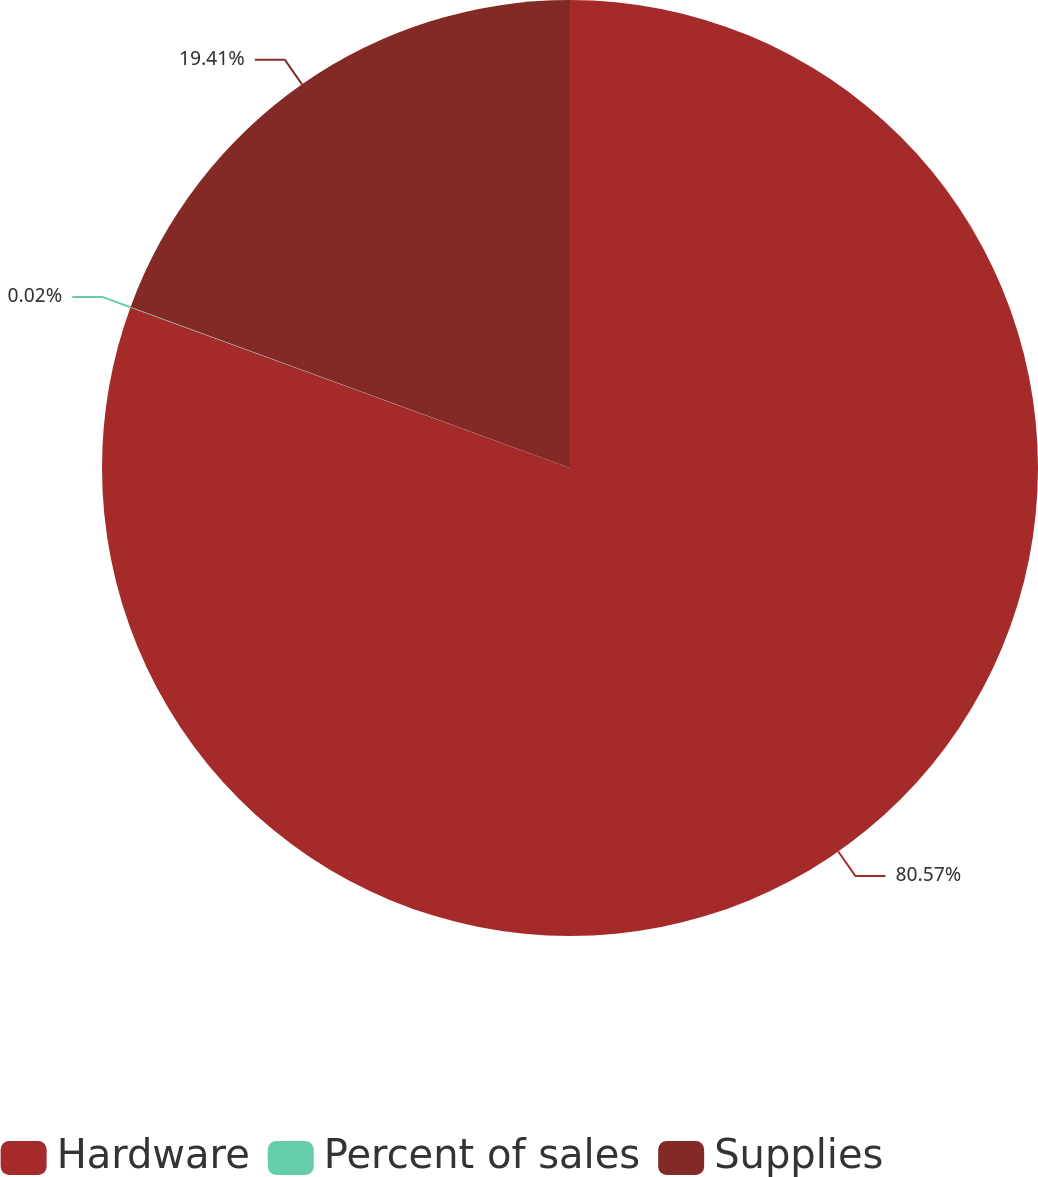Convert chart. <chart><loc_0><loc_0><loc_500><loc_500><pie_chart><fcel>Hardware<fcel>Percent of sales<fcel>Supplies<nl><fcel>80.58%<fcel>0.02%<fcel>19.41%<nl></chart> 